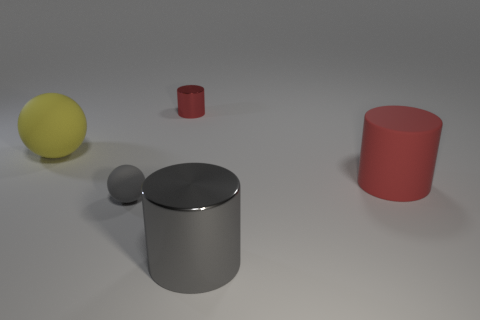Add 5 small cyan rubber cylinders. How many objects exist? 10 Subtract all spheres. How many objects are left? 3 Add 3 yellow matte spheres. How many yellow matte spheres are left? 4 Add 5 red rubber cylinders. How many red rubber cylinders exist? 6 Subtract 0 cyan cylinders. How many objects are left? 5 Subtract all spheres. Subtract all large matte cylinders. How many objects are left? 2 